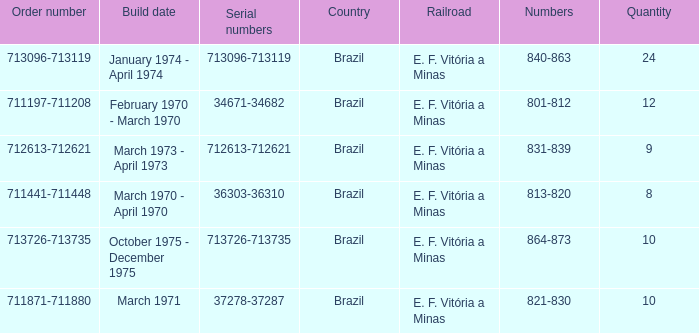What are the numbers for the order number 713096-713119? 840-863. 